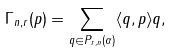Convert formula to latex. <formula><loc_0><loc_0><loc_500><loc_500>\Gamma _ { n , r } ( p ) = \sum _ { q \in P _ { r , n } ( \alpha ) } \langle q , p \rangle q ,</formula> 